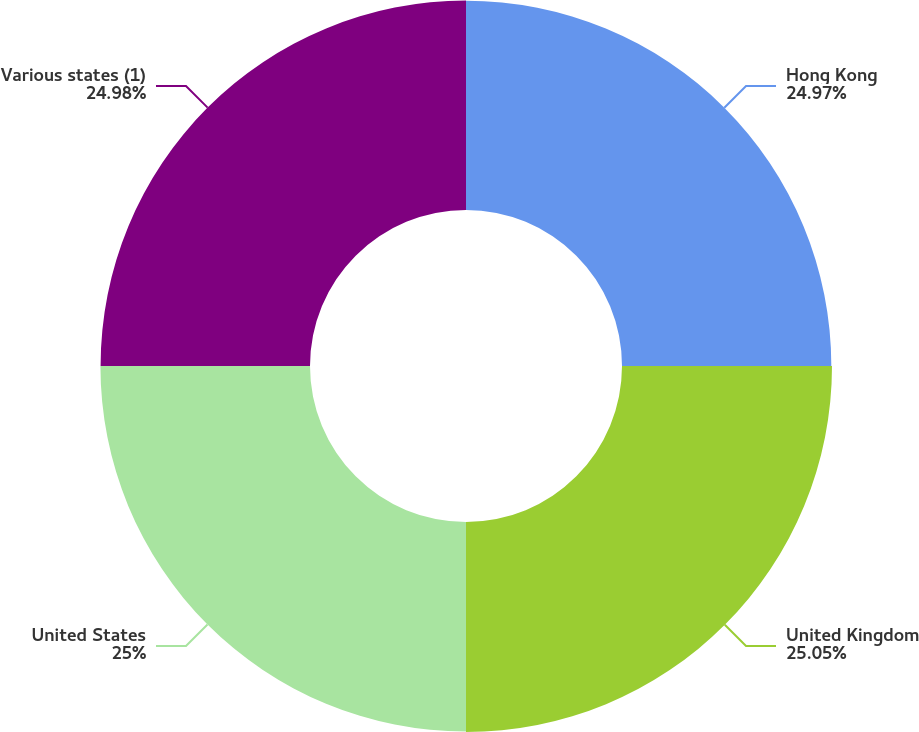Convert chart. <chart><loc_0><loc_0><loc_500><loc_500><pie_chart><fcel>Hong Kong<fcel>United Kingdom<fcel>United States<fcel>Various states (1)<nl><fcel>24.97%<fcel>25.05%<fcel>25.0%<fcel>24.98%<nl></chart> 